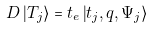<formula> <loc_0><loc_0><loc_500><loc_500>D \left | T _ { j } \right \rangle = t _ { e } \left | t _ { j } , q , \Psi _ { j } \right \rangle</formula> 